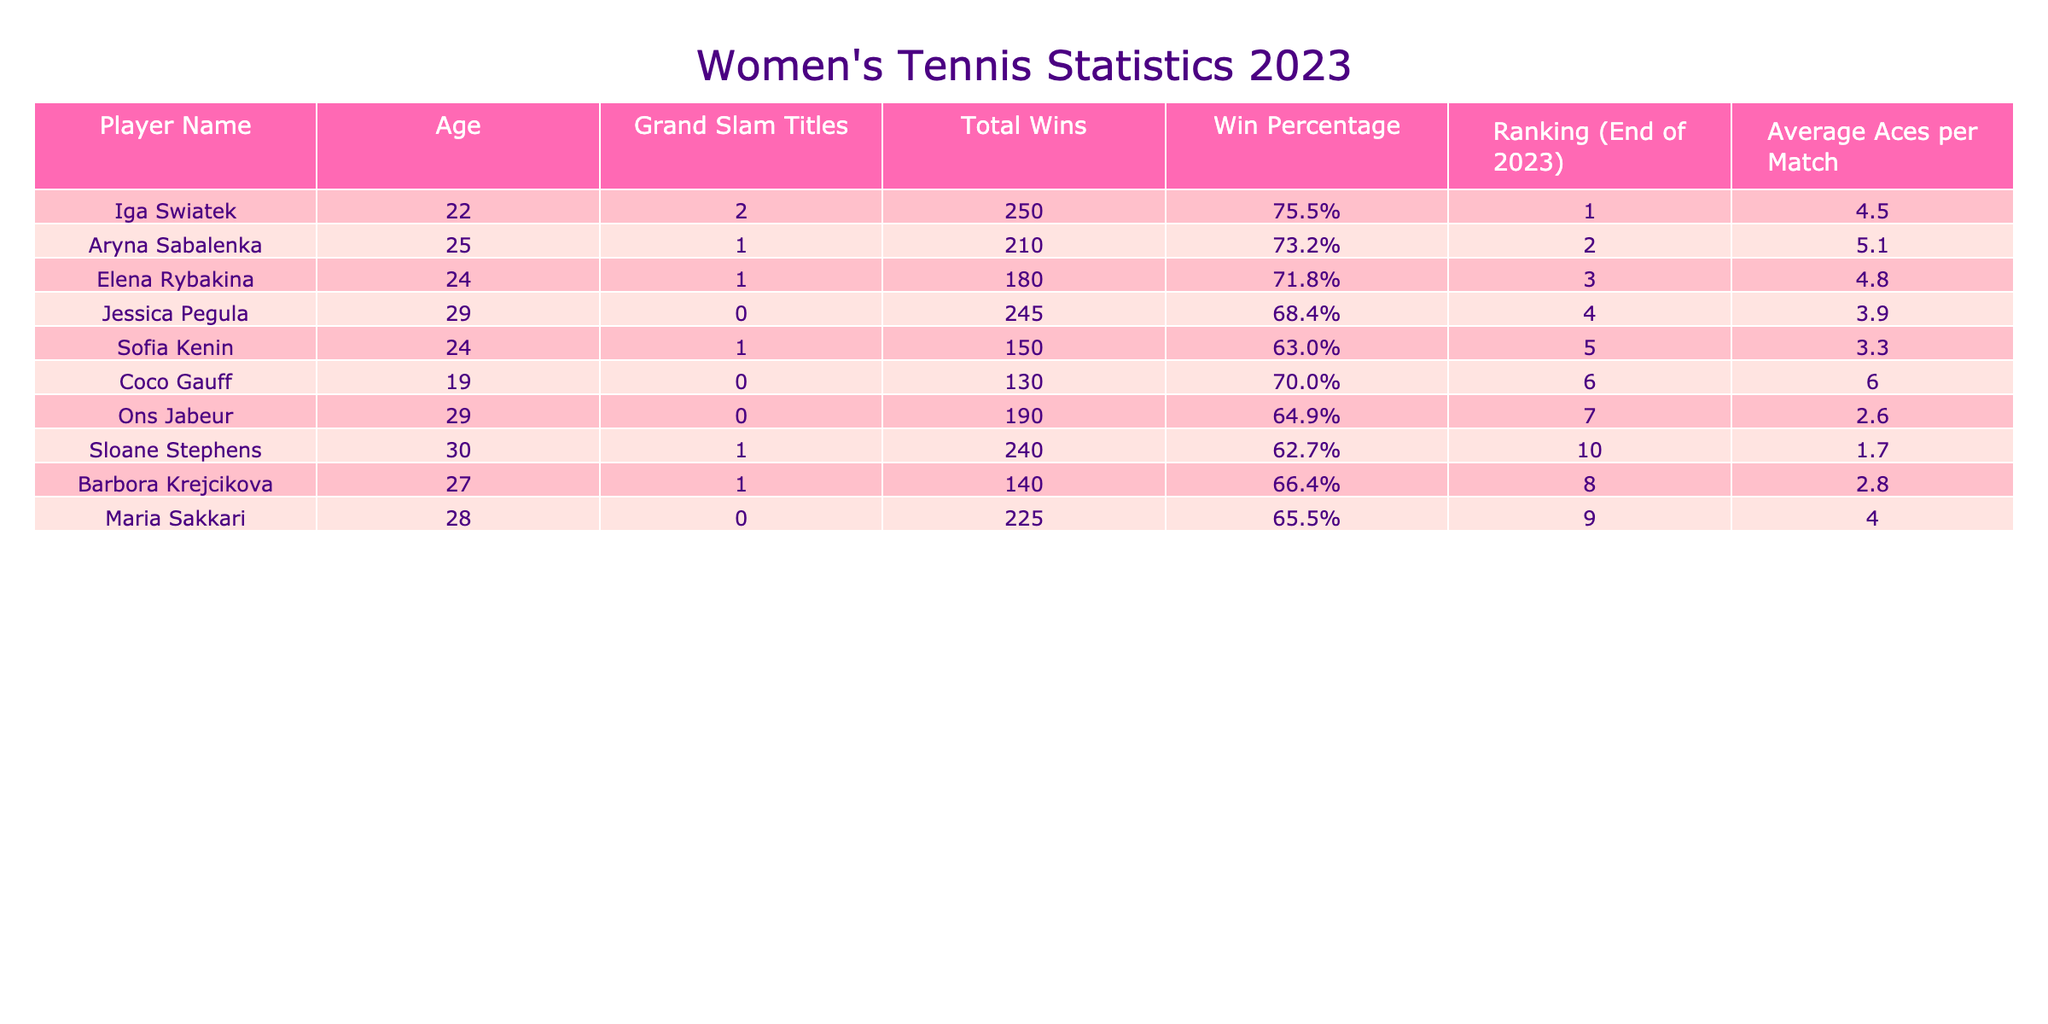What is the age of Sloane Stephens? According to the table, the age of Sloane Stephens is listed in the 'Age' column beside her name. The value is 30.
Answer: 30 Who has the highest win percentage among the players? To find the highest win percentage, we compare the values in the 'Win Percentage' column. Iga Swiatek has the highest at 75.5%.
Answer: Iga Swiatek Is there any player aged 19 who has won a Grand Slam title? Examining the data, Coco Gauff, aged 19, is listed with 0 Grand Slam titles. Hence, there is no player aged 19 with a Grand Slam title.
Answer: No What is the average age of players with Grand Slam titles? The players with Grand Slam titles are Iga Swiatek, Aryna Sabalenka, Elena Rybakina, Sofia Kenin, and Sloane Stephens, whose ages are 22, 25, 24, 24, and 30 respectively. The average age is (22 + 25 + 24 + 24 + 30) / 5 = 25.
Answer: 25 Which player has the most total wins and what is that number? The 'Total Wins' column shows that Jessica Pegula has the most wins at 245. We can confirm this by looking at the total wins values for all players.
Answer: 245 Does every player over the age of 25 have a winning percentage above 65%? By examining the players aged over 25, we see that Jessica Pegula (29, 68.4%), Ons Jabeur (29, 64.9%), Maria Sakkari (28, 65.5%), and Barbora Krejcikova (27, 66.4%) all have win percentages above 65%. However, Sloane Stephens (30, 62.7%) does not meet this criterion.
Answer: No What is the difference in average aces per match between the youngest and oldest players? The youngest player is Coco Gauff with an average of 6.0 aces per match, and the oldest player, Sloane Stephens, has an average of 1.7 aces per match. Calculating the difference: 6.0 - 1.7 = 4.3.
Answer: 4.3 How many players have a win percentage lower than 65%? Looking at the 'Win Percentage' column, we find Sofia Kenin (63.0%), Ons Jabeur (64.9%), and Sloane Stephens (62.7%). There are 3 players with a win percentage lower than 65%.
Answer: 3 Which player with the highest ranking has never won a Grand Slam title? The player with a ranking of 4, Jessica Pegula, has never won a Grand Slam title according to the 'Grand Slam Titles' column.
Answer: Jessica Pegula 